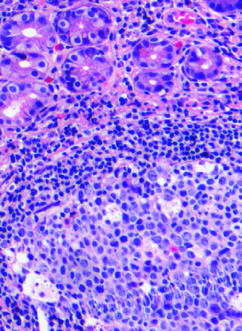what are lymphoid aggregates with germinal centers and abundant subepi-thelial plasma cells within the superficial lamina propria?
Answer the question using a single word or phrase. Characteristics of h pylori gastritis 